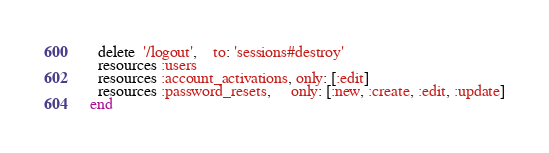Convert code to text. <code><loc_0><loc_0><loc_500><loc_500><_Ruby_>  delete  '/logout',    to: 'sessions#destroy'
  resources :users
  resources :account_activations, only: [:edit]
  resources :password_resets,     only: [:new, :create, :edit, :update]
end
</code> 